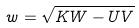Convert formula to latex. <formula><loc_0><loc_0><loc_500><loc_500>w = \sqrt { K W - U V }</formula> 